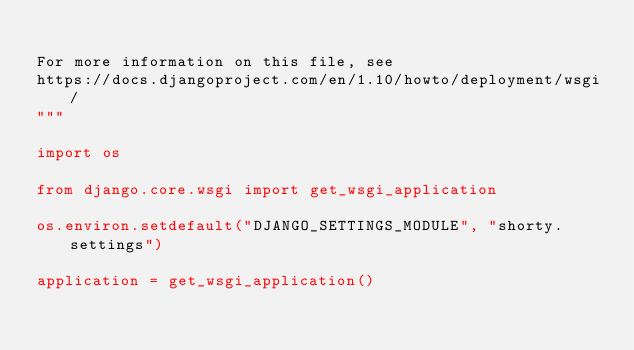<code> <loc_0><loc_0><loc_500><loc_500><_Python_>
For more information on this file, see
https://docs.djangoproject.com/en/1.10/howto/deployment/wsgi/
"""

import os

from django.core.wsgi import get_wsgi_application

os.environ.setdefault("DJANGO_SETTINGS_MODULE", "shorty.settings")

application = get_wsgi_application()
</code> 